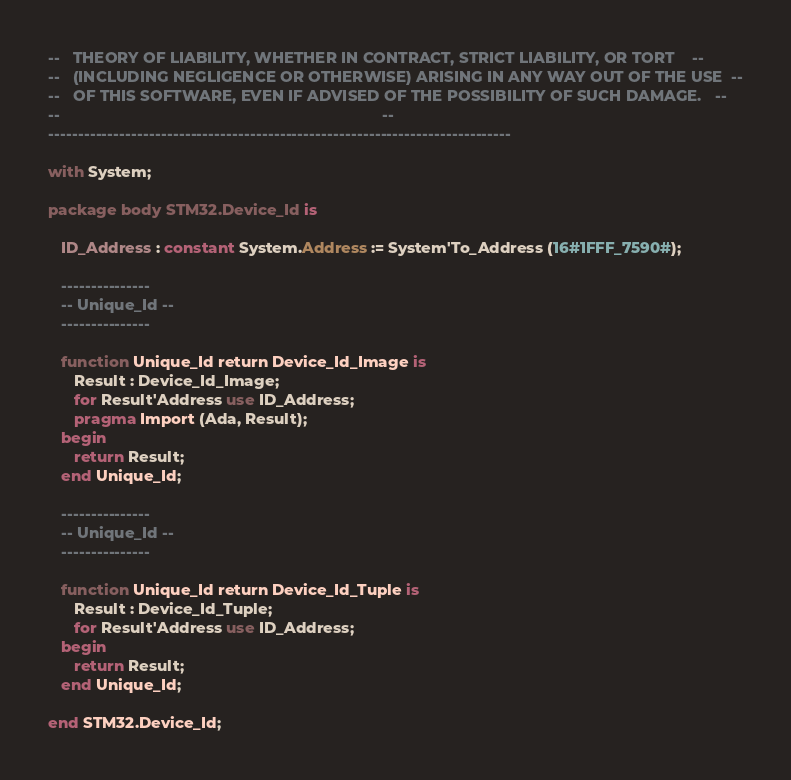Convert code to text. <code><loc_0><loc_0><loc_500><loc_500><_Ada_>--   THEORY OF LIABILITY, WHETHER IN CONTRACT, STRICT LIABILITY, OR TORT    --
--   (INCLUDING NEGLIGENCE OR OTHERWISE) ARISING IN ANY WAY OUT OF THE USE  --
--   OF THIS SOFTWARE, EVEN IF ADVISED OF THE POSSIBILITY OF SUCH DAMAGE.   --
--                                                                          --
------------------------------------------------------------------------------

with System;

package body STM32.Device_Id is

   ID_Address : constant System.Address := System'To_Address (16#1FFF_7590#);

   ---------------
   -- Unique_Id --
   ---------------

   function Unique_Id return Device_Id_Image is
      Result : Device_Id_Image;
      for Result'Address use ID_Address;
      pragma Import (Ada, Result);
   begin
      return Result;
   end Unique_Id;

   ---------------
   -- Unique_Id --
   ---------------

   function Unique_Id return Device_Id_Tuple is
      Result : Device_Id_Tuple;
      for Result'Address use ID_Address;
   begin
      return Result;
   end Unique_Id;

end STM32.Device_Id;
</code> 